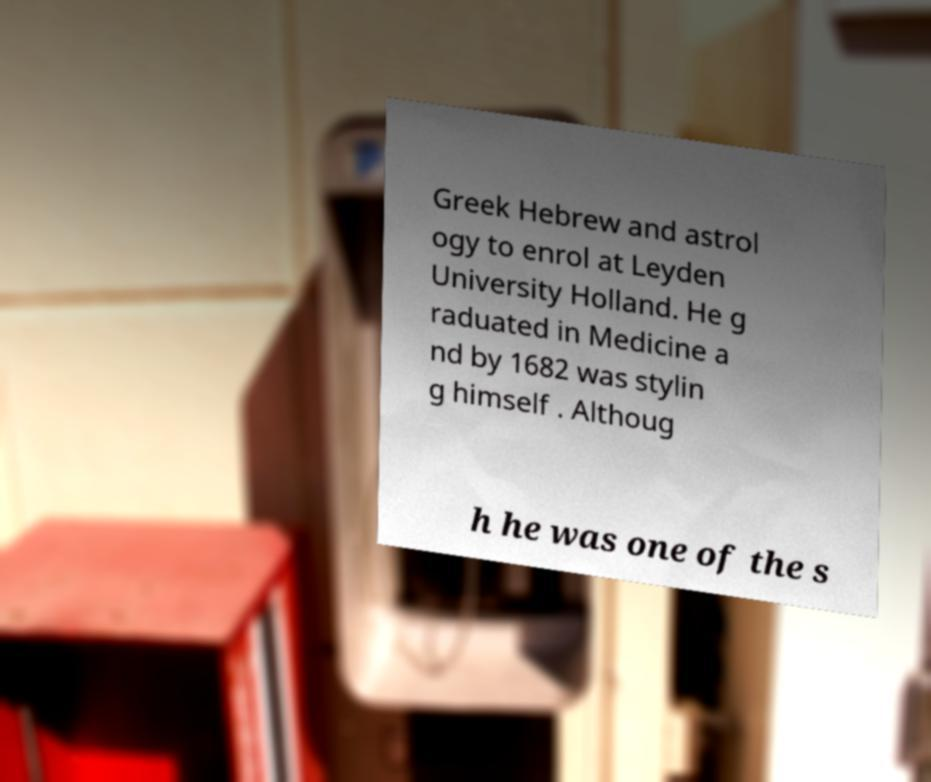What messages or text are displayed in this image? I need them in a readable, typed format. Greek Hebrew and astrol ogy to enrol at Leyden University Holland. He g raduated in Medicine a nd by 1682 was stylin g himself . Althoug h he was one of the s 